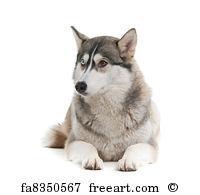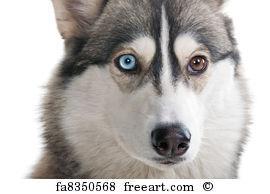The first image is the image on the left, the second image is the image on the right. Examine the images to the left and right. Is the description "The left and right image contains the same number of wolves." accurate? Answer yes or no. Yes. 